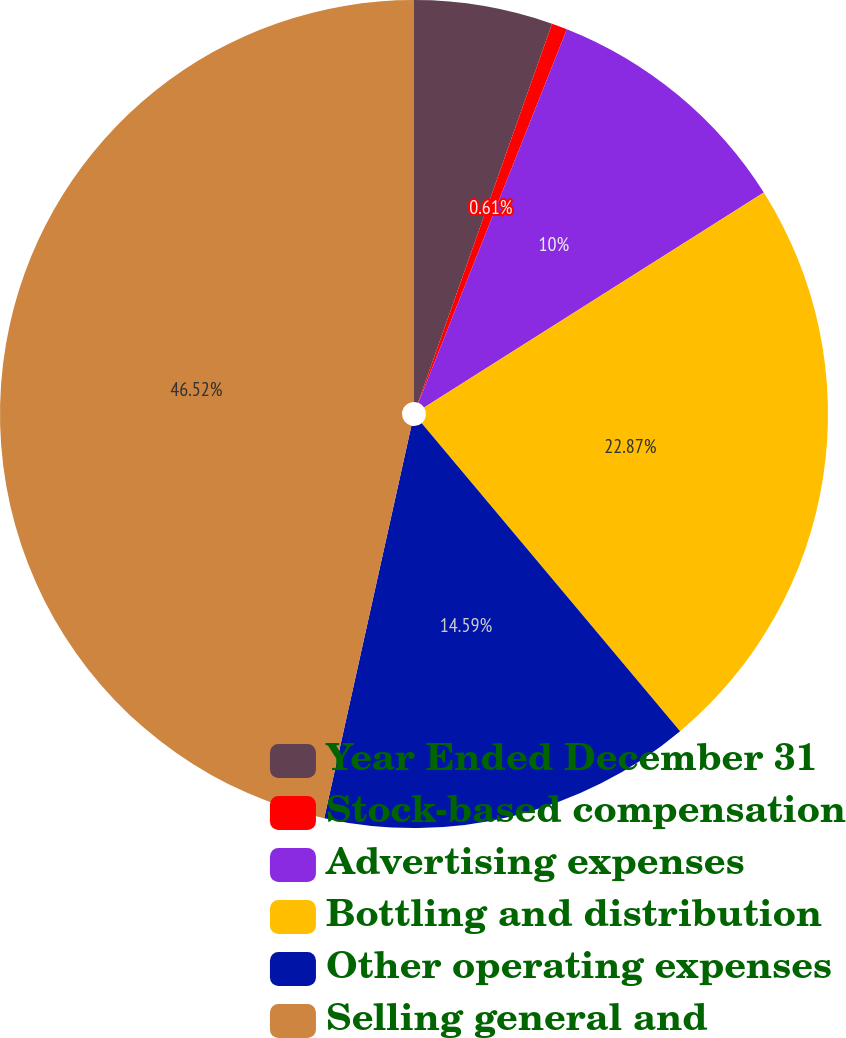Convert chart. <chart><loc_0><loc_0><loc_500><loc_500><pie_chart><fcel>Year Ended December 31<fcel>Stock-based compensation<fcel>Advertising expenses<fcel>Bottling and distribution<fcel>Other operating expenses<fcel>Selling general and<nl><fcel>5.41%<fcel>0.61%<fcel>10.0%<fcel>22.87%<fcel>14.59%<fcel>46.52%<nl></chart> 